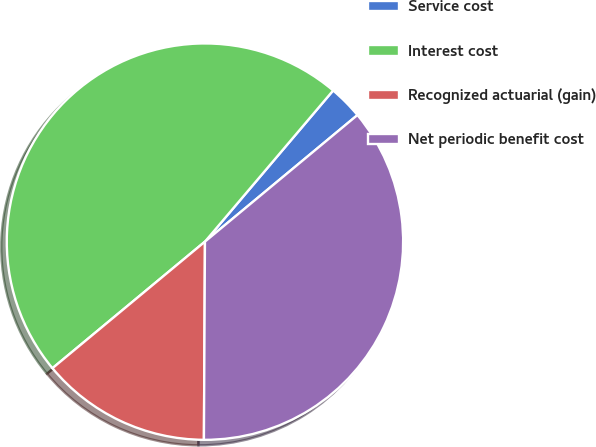Convert chart. <chart><loc_0><loc_0><loc_500><loc_500><pie_chart><fcel>Service cost<fcel>Interest cost<fcel>Recognized actuarial (gain)<fcel>Net periodic benefit cost<nl><fcel>2.78%<fcel>47.22%<fcel>13.89%<fcel>36.11%<nl></chart> 